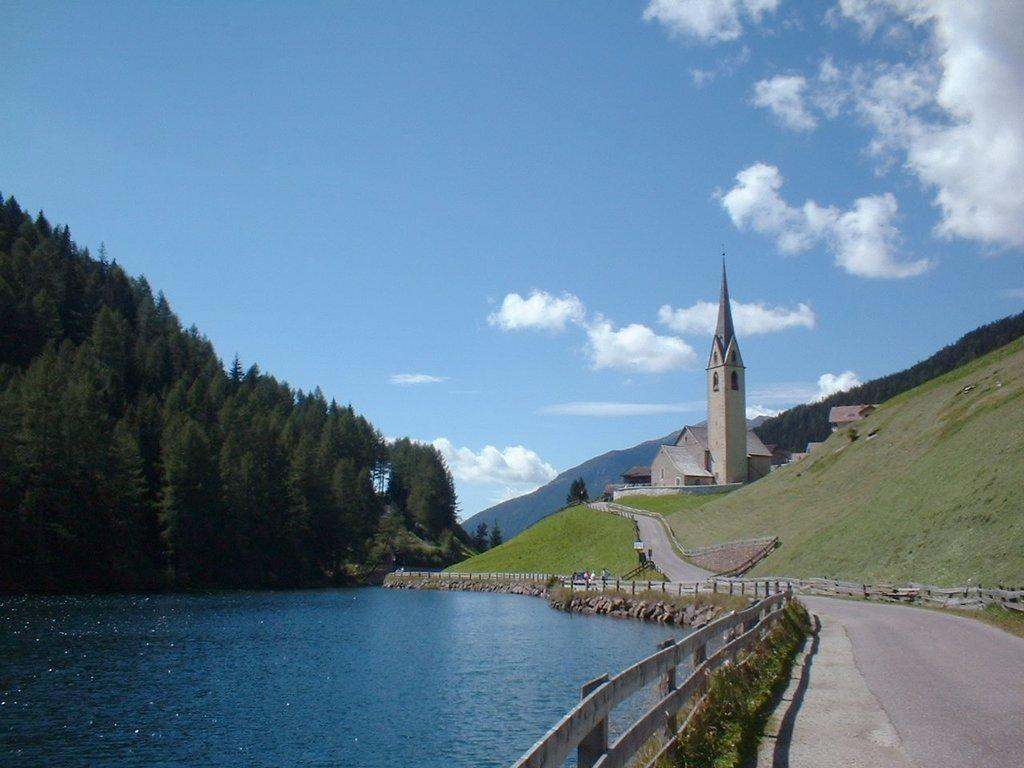What are the people in the image doing? The people in the image are standing near a fence. What can be seen near the people? There is water visible near the people. What type of natural environment is present in the image? There are trees in the vicinity. What is visible in the background of the image? There are houses and clouds in the background. What type of arch can be seen in the image? There is no arch present in the image. What mode of transportation is being used by the people in the image? The image does not show any mode of transportation being used by the people. 